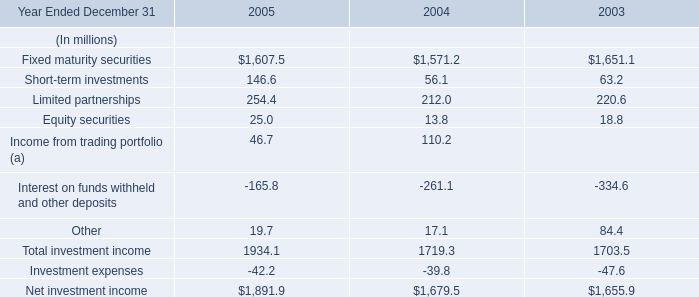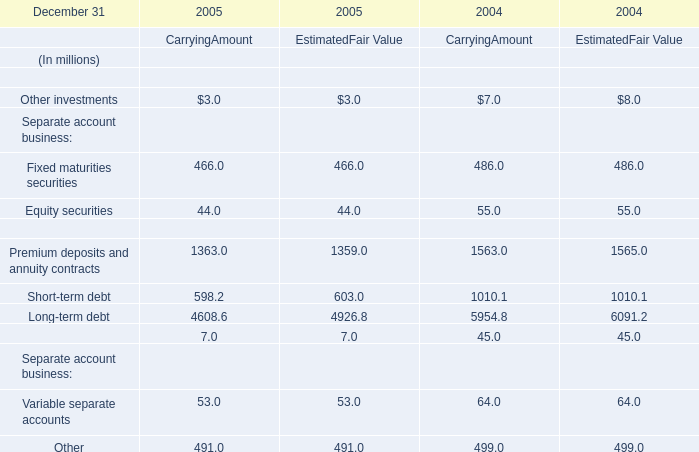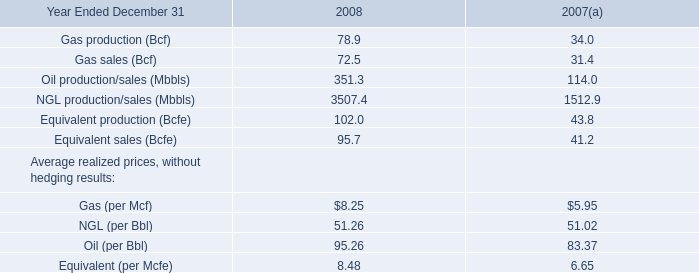In which year is Carrying Amount of Fixed maturities securities greater than 470 million? 
Answer: 2004. 